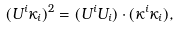<formula> <loc_0><loc_0><loc_500><loc_500>( U ^ { i } \kappa _ { i } ) ^ { 2 } = ( U ^ { i } U _ { i } ) \cdot ( \kappa ^ { i } \kappa _ { i } ) ,</formula> 